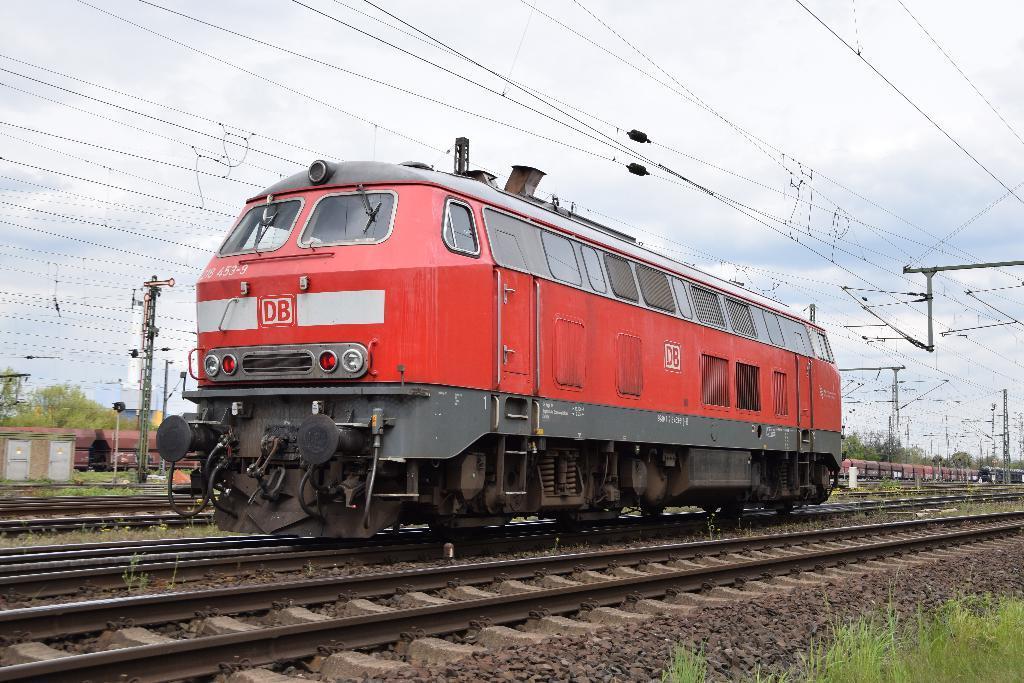Describe this image in one or two sentences. In this image I can see few trains on the railway tracks. I can see few current poles, wires, trees, small stones and the green grass. The sky is in white and blue color. 